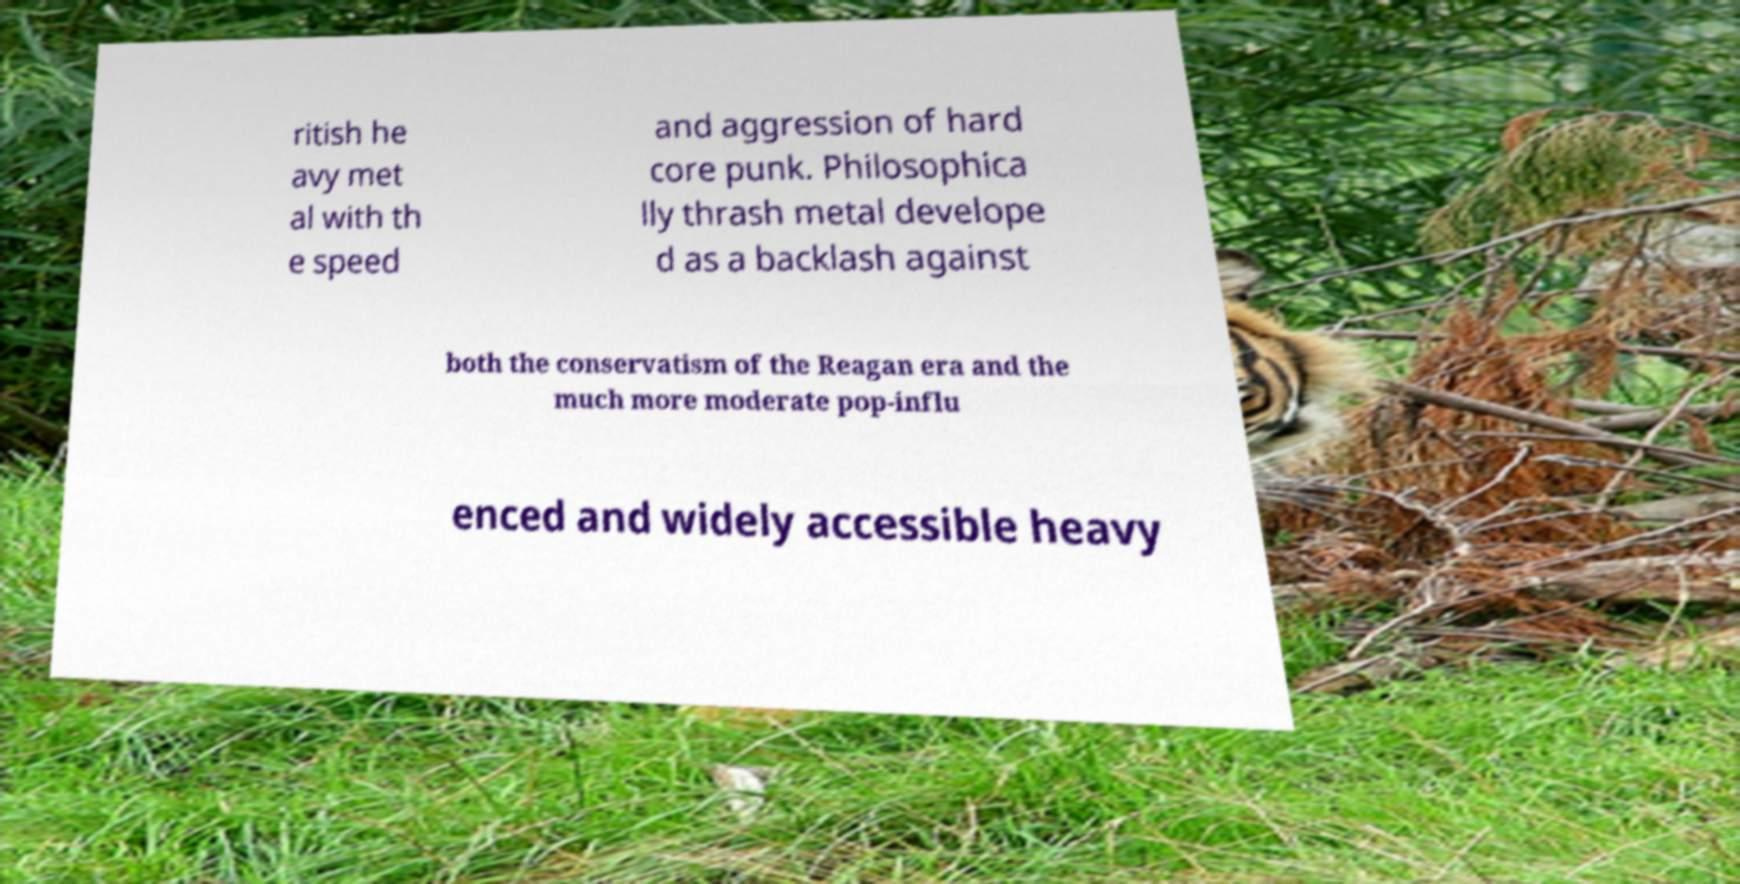For documentation purposes, I need the text within this image transcribed. Could you provide that? ritish he avy met al with th e speed and aggression of hard core punk. Philosophica lly thrash metal develope d as a backlash against both the conservatism of the Reagan era and the much more moderate pop-influ enced and widely accessible heavy 